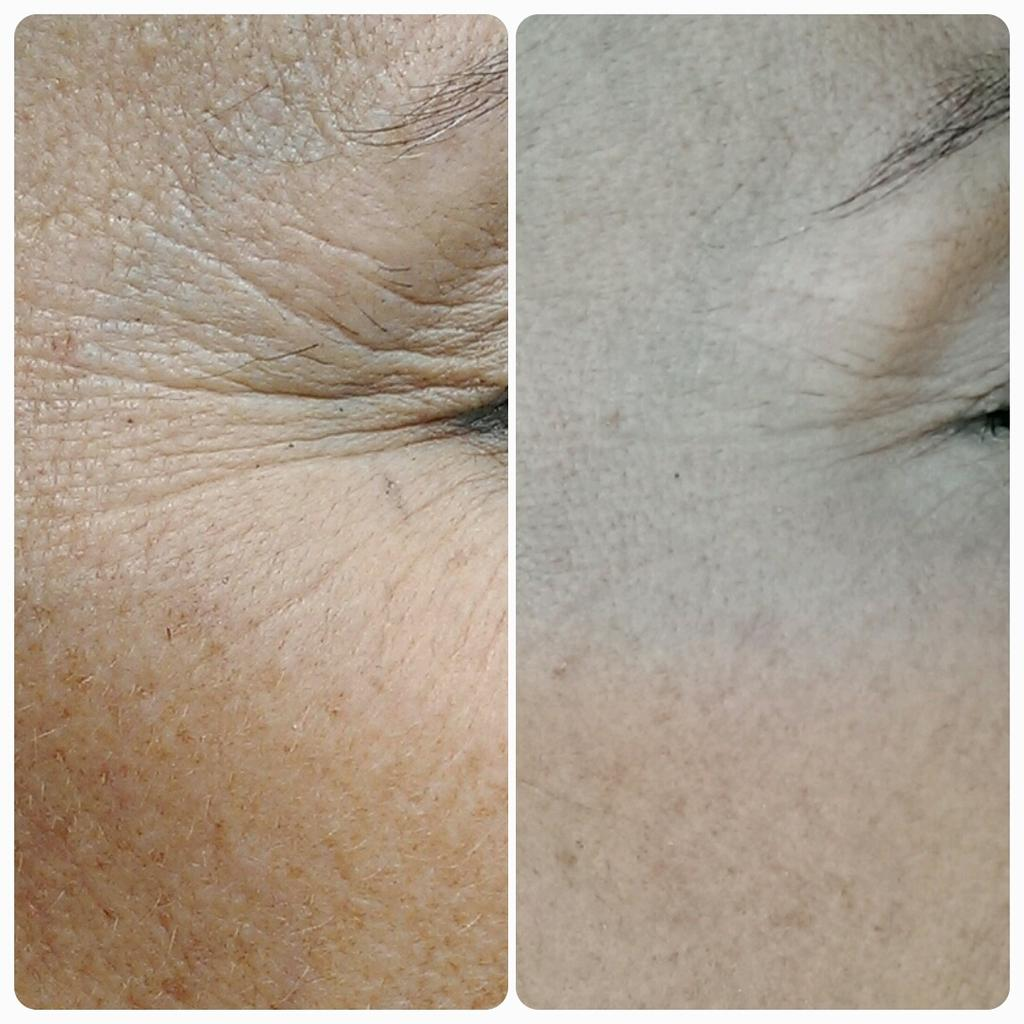What type of artwork is featured in the image? The image contains a collage. Can you describe any specific elements within the collage? The skin of a person is visible in the collage. What type of table is depicted in the cave during the journey in the image? There is no table, cave, or journey present in the image; it contains a collage with the skin of a person visible. 